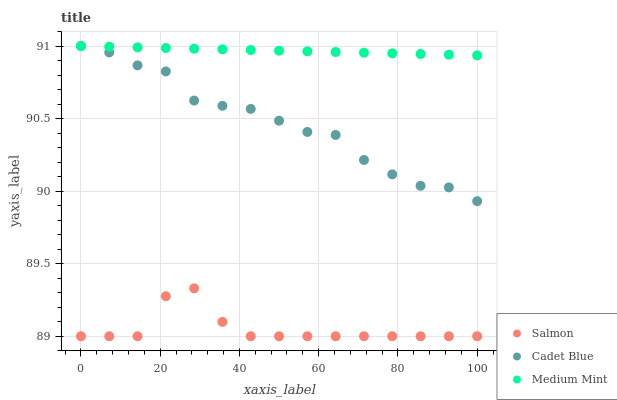Does Salmon have the minimum area under the curve?
Answer yes or no. Yes. Does Medium Mint have the maximum area under the curve?
Answer yes or no. Yes. Does Cadet Blue have the minimum area under the curve?
Answer yes or no. No. Does Cadet Blue have the maximum area under the curve?
Answer yes or no. No. Is Medium Mint the smoothest?
Answer yes or no. Yes. Is Salmon the roughest?
Answer yes or no. Yes. Is Cadet Blue the smoothest?
Answer yes or no. No. Is Cadet Blue the roughest?
Answer yes or no. No. Does Salmon have the lowest value?
Answer yes or no. Yes. Does Cadet Blue have the lowest value?
Answer yes or no. No. Does Cadet Blue have the highest value?
Answer yes or no. Yes. Does Salmon have the highest value?
Answer yes or no. No. Is Salmon less than Medium Mint?
Answer yes or no. Yes. Is Cadet Blue greater than Salmon?
Answer yes or no. Yes. Does Cadet Blue intersect Medium Mint?
Answer yes or no. Yes. Is Cadet Blue less than Medium Mint?
Answer yes or no. No. Is Cadet Blue greater than Medium Mint?
Answer yes or no. No. Does Salmon intersect Medium Mint?
Answer yes or no. No. 